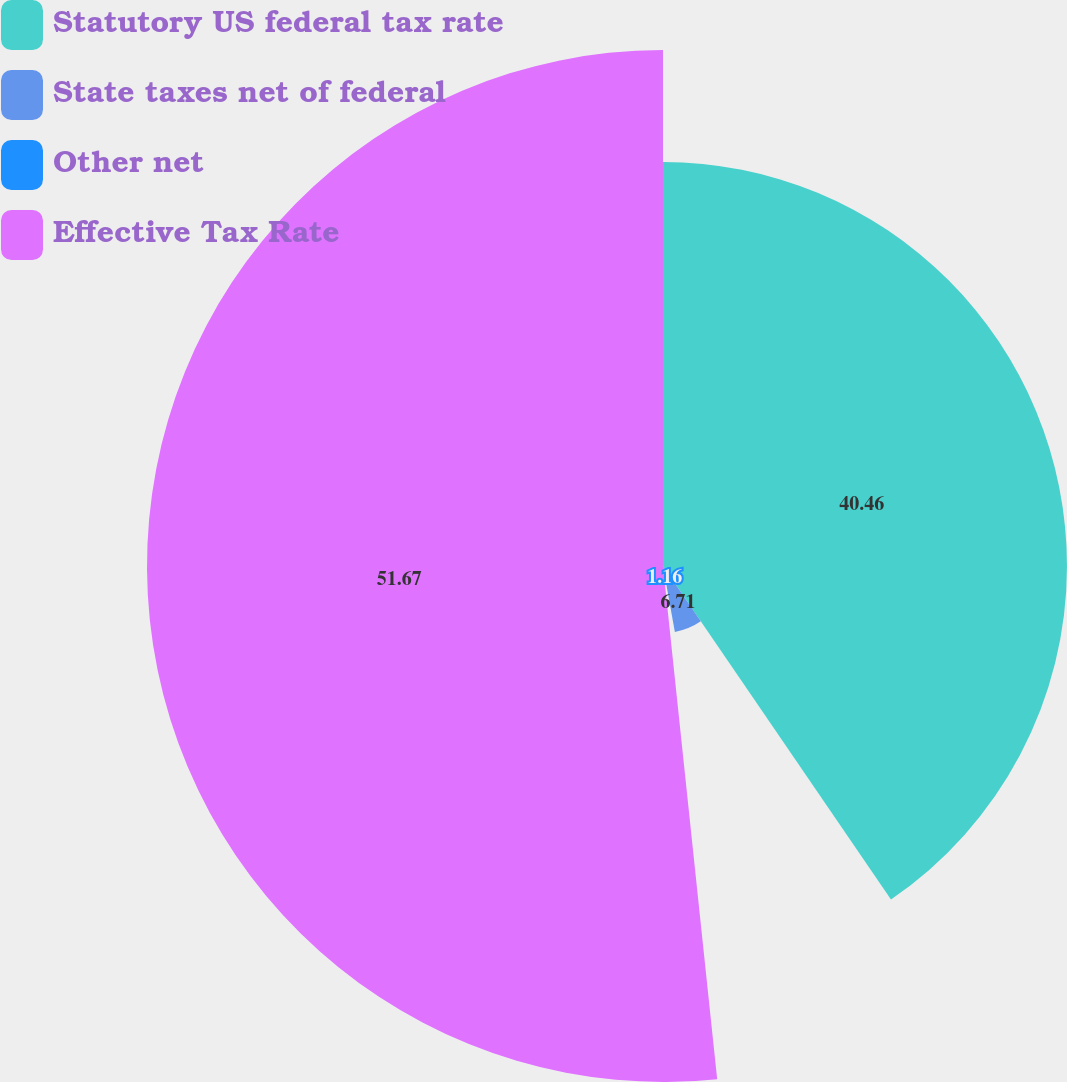Convert chart to OTSL. <chart><loc_0><loc_0><loc_500><loc_500><pie_chart><fcel>Statutory US federal tax rate<fcel>State taxes net of federal<fcel>Other net<fcel>Effective Tax Rate<nl><fcel>40.46%<fcel>6.71%<fcel>1.16%<fcel>51.68%<nl></chart> 